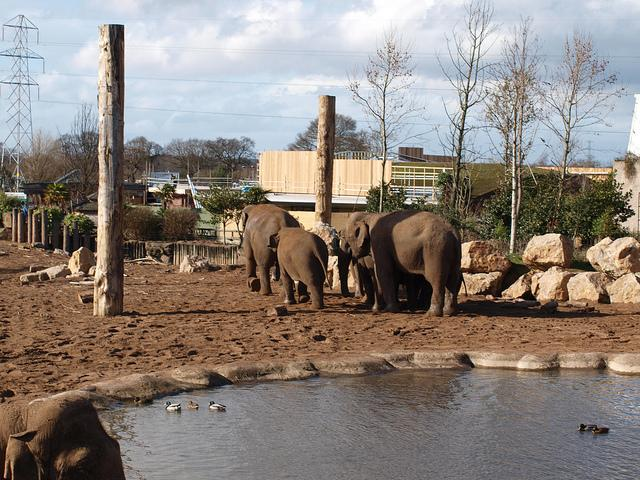What body of water is this?

Choices:
A) pool
B) pond
C) ocean
D) swamp pond 